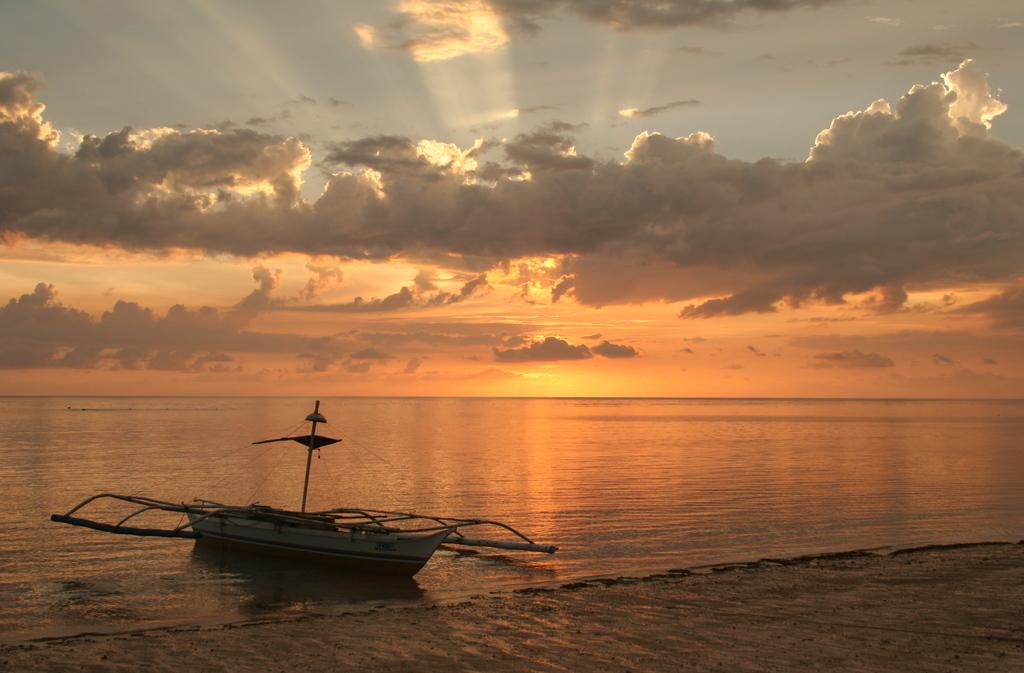What type of location is depicted in the image? The image is a beach scene. What can be seen on the left side of the image? There is a boat on the water on the left side of the image. What is visible at the top of the image? The sky is visible at the top of the image. What can be observed in the sky? Clouds are present in the sky. What type of seed is growing on the page in the image? There is no seed or page present in the image; it is a beach scene with a boat on the water and clouds in the sky. 